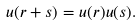Convert formula to latex. <formula><loc_0><loc_0><loc_500><loc_500>u ( r + s ) = u ( r ) u ( s ) .</formula> 